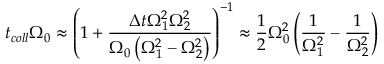<formula> <loc_0><loc_0><loc_500><loc_500>t _ { c o l l } \Omega _ { 0 } \approx \left ( 1 + \frac { { \Delta t } \Omega _ { 1 } ^ { 2 } \Omega _ { 2 } ^ { 2 } } { \Omega _ { 0 } \left ( \Omega _ { 1 } ^ { 2 } - \Omega _ { 2 } ^ { 2 } \right ) } \right ) ^ { - 1 } \approx \frac { 1 } { 2 } \Omega _ { 0 } ^ { 2 } \left ( \frac { 1 } { \Omega _ { 1 } ^ { 2 } } - \frac { 1 } { \Omega _ { 2 } ^ { 2 } } \right )</formula> 